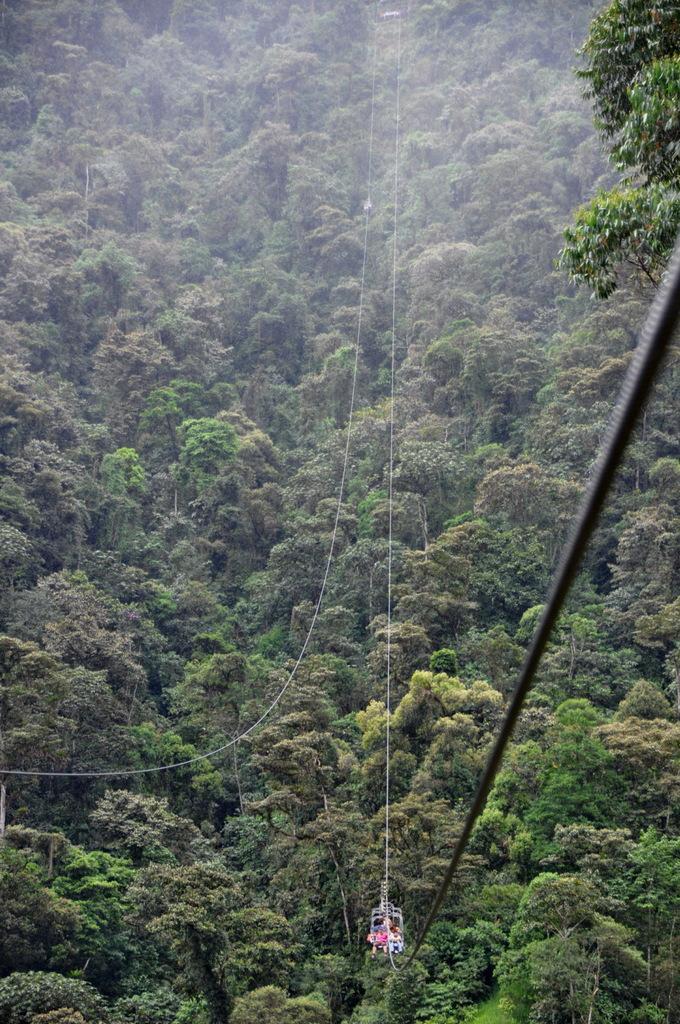Please provide a concise description of this image. This is an aerial view. In the center of the image we can see the ropeway. In the background of the image we can see the trees. 